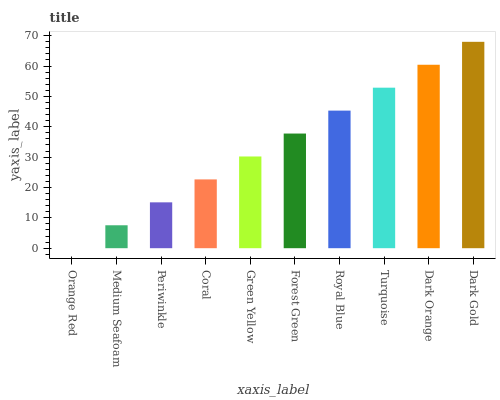Is Orange Red the minimum?
Answer yes or no. Yes. Is Dark Gold the maximum?
Answer yes or no. Yes. Is Medium Seafoam the minimum?
Answer yes or no. No. Is Medium Seafoam the maximum?
Answer yes or no. No. Is Medium Seafoam greater than Orange Red?
Answer yes or no. Yes. Is Orange Red less than Medium Seafoam?
Answer yes or no. Yes. Is Orange Red greater than Medium Seafoam?
Answer yes or no. No. Is Medium Seafoam less than Orange Red?
Answer yes or no. No. Is Forest Green the high median?
Answer yes or no. Yes. Is Green Yellow the low median?
Answer yes or no. Yes. Is Orange Red the high median?
Answer yes or no. No. Is Periwinkle the low median?
Answer yes or no. No. 